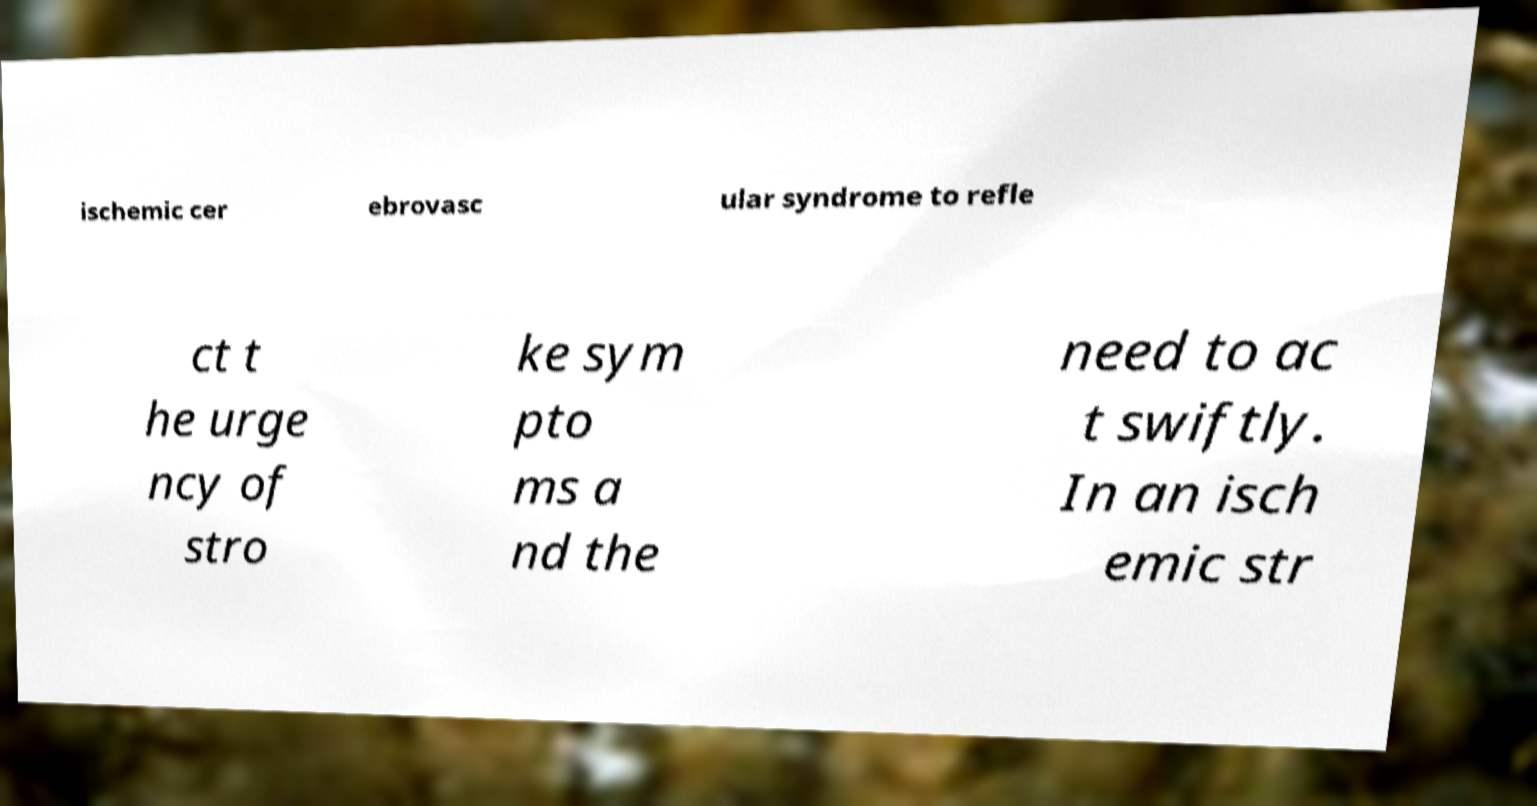There's text embedded in this image that I need extracted. Can you transcribe it verbatim? ischemic cer ebrovasc ular syndrome to refle ct t he urge ncy of stro ke sym pto ms a nd the need to ac t swiftly. In an isch emic str 